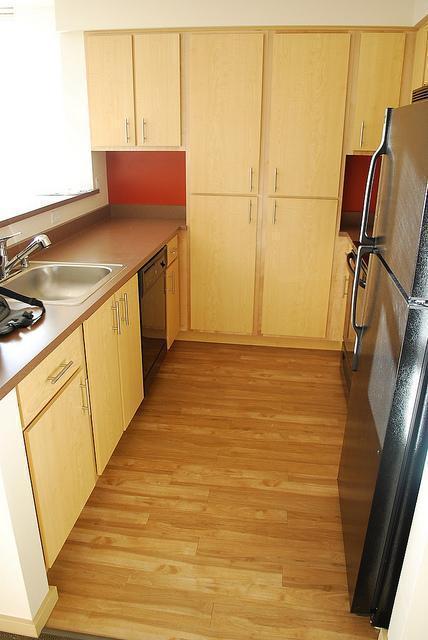What is going on with this room?
Indicate the correct choice and explain in the format: 'Answer: answer
Rationale: rationale.'
Options: Dirty, being painted, being remodeled, no occupant. Answer: no occupant.
Rationale: You can easily tell by the picture as to what or who is missing from it. 